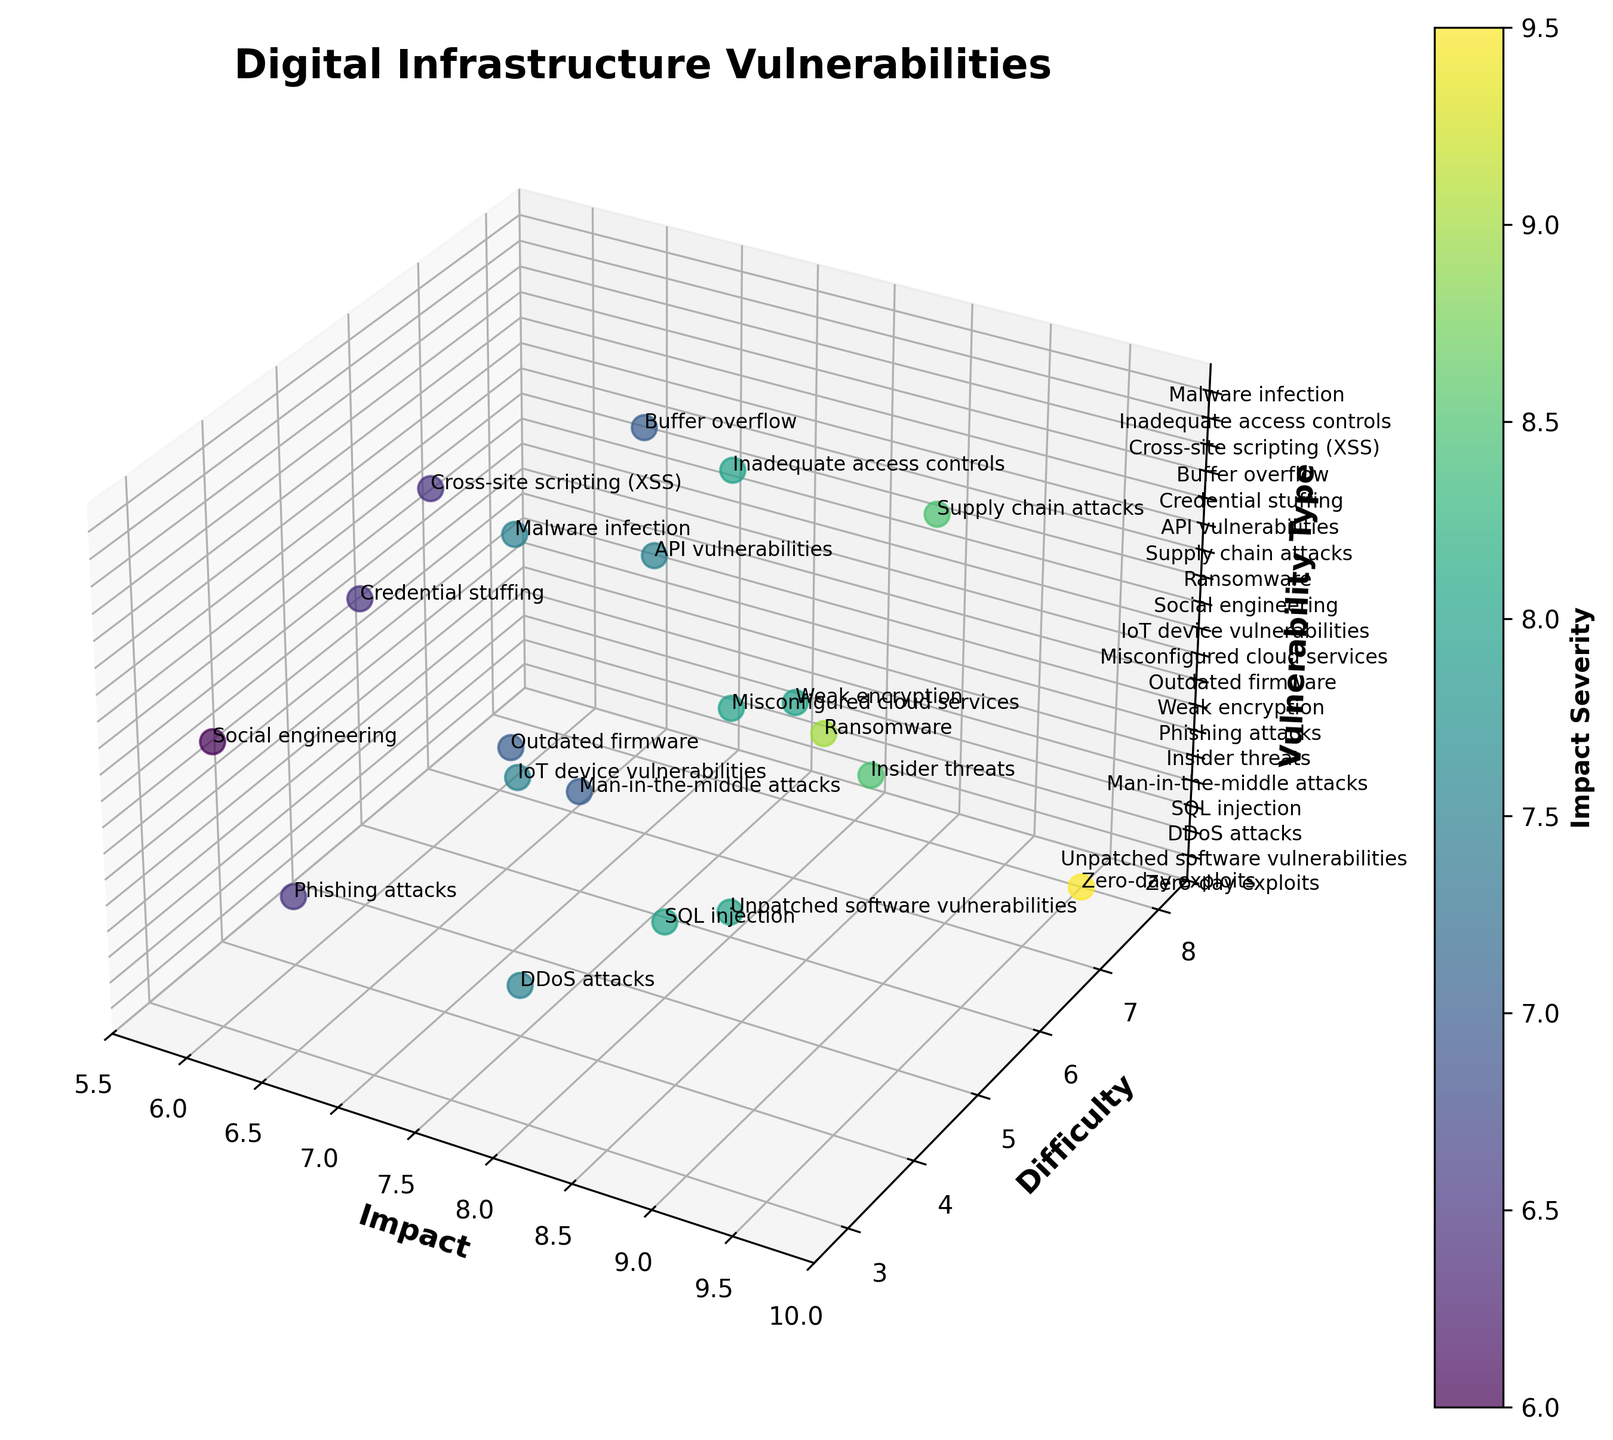What is the title of the plot? To find the title, look at the top of the plot, where the main heading is usually placed. In this figure, the title is written in a bold, larger font for easy identification.
Answer: Digital Infrastructure Vulnerabilities Which vulnerability type has the highest impact? Examine the "Impact" axis of the 3D scatter plot and identify the data point that is at the highest position on this axis. The associated label will provide the type.
Answer: Zero-day exploits What is the range of the "Difficulty" axis? Look at the "Difficulty" axis and identify the values at the start and end points to determine the range.
Answer: 2.5 to 8.5 Which type of vulnerability is the hardest to exploit but has a high potential impact? Identify the vulnerabilities that are both high on the "Impact" axis and high on the "Difficulty" axis. The corresponding labels will give you the type.
Answer: Zero-day exploits How many vulnerabilities have an impact score of at least 8? Count the data points that lie on or above the line corresponding to "Impact" = 8 on the "Impact" axis.
Answer: 11 Compare the difficulties of DDoS attacks and SQL injection. Which one is harder to exploit? Locate the positions of DDoS attacks and SQL injection on the "Difficulty" axis, then compare their values.
Answer: SQL injection What is the median difficulty level of all vulnerabilities shown? Arrange the difficulty levels in ascending order and find the middle value. If there's an even number of values, calculate the average of the two middle numbers.
Answer: 5.5 Which vulnerability type has an impact score higher than phishing attacks but a lower difficulty score? Compare the "Impact" and "Difficulty" values of phishing attacks to other vulnerabilities, identifying one that meets both criteria.
Answer: Ransomware How many vulnerabilities have a difficulty score of 6? Count the data points situated at 6 on the "Difficulty" axis, where the associated labels indicate the type.
Answer: 4 What is the average impact score of vulnerabilities with a difficulty score of 7? Identify all vulnerabilities with a difficulty score of 7 and compute the average of their impact scores.
Answer: (8.5 + 8 + 7) / 3 = 7.83 